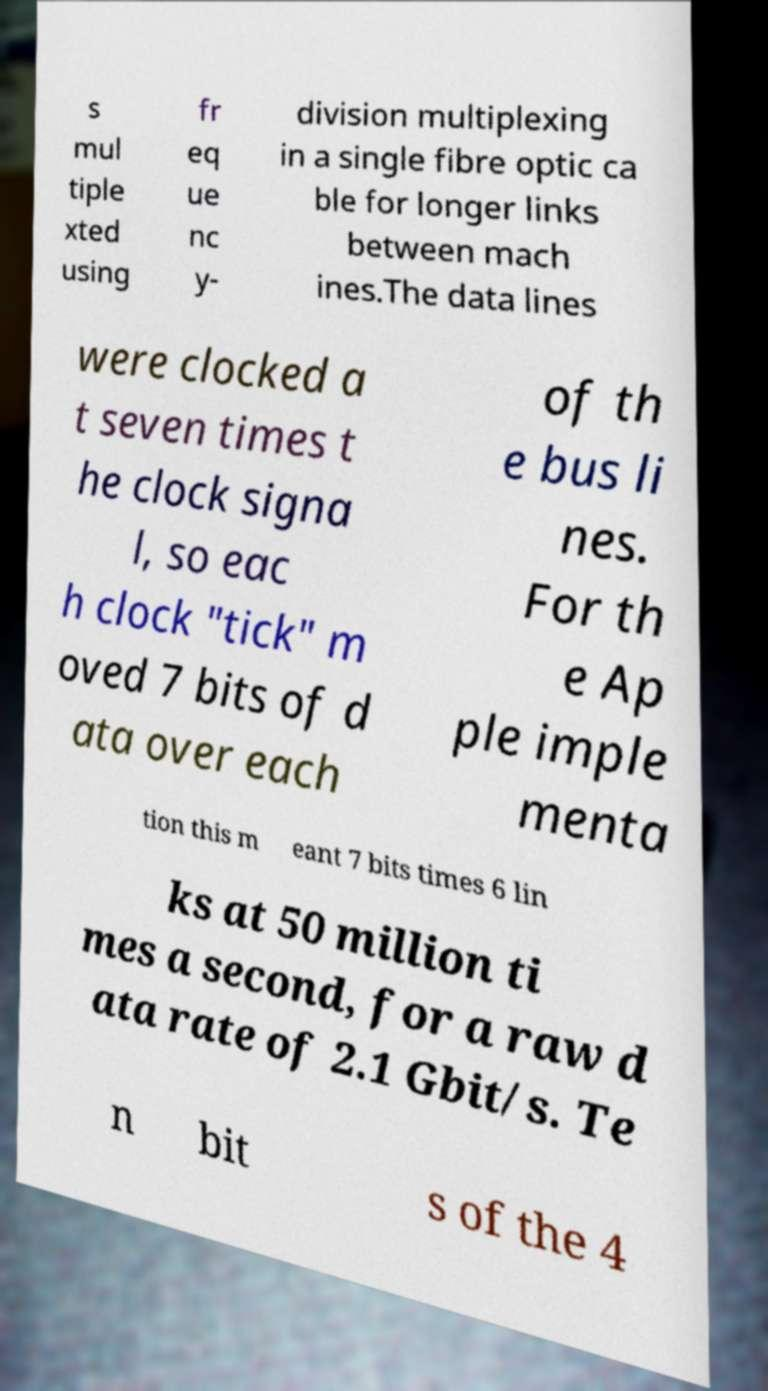Could you extract and type out the text from this image? s mul tiple xted using fr eq ue nc y- division multiplexing in a single fibre optic ca ble for longer links between mach ines.The data lines were clocked a t seven times t he clock signa l, so eac h clock "tick" m oved 7 bits of d ata over each of th e bus li nes. For th e Ap ple imple menta tion this m eant 7 bits times 6 lin ks at 50 million ti mes a second, for a raw d ata rate of 2.1 Gbit/s. Te n bit s of the 4 